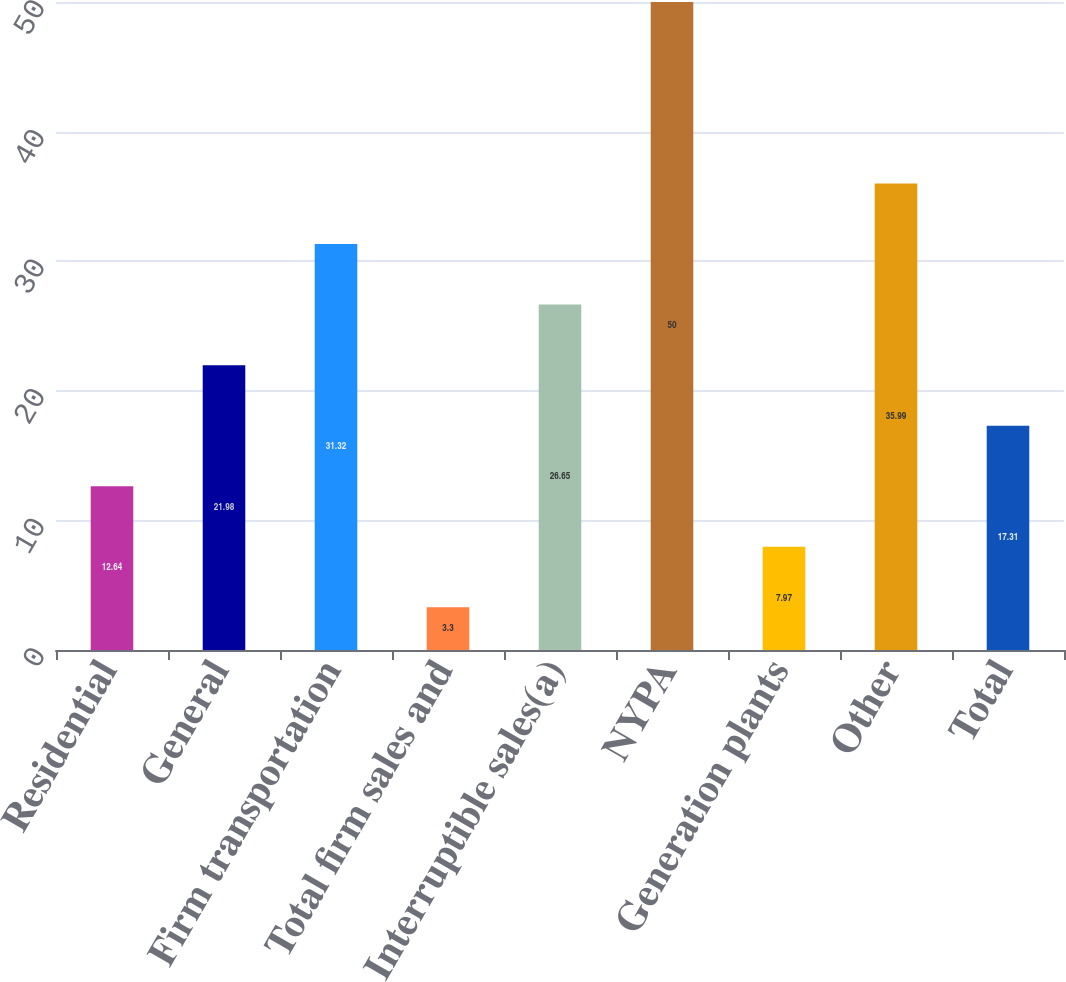Convert chart. <chart><loc_0><loc_0><loc_500><loc_500><bar_chart><fcel>Residential<fcel>General<fcel>Firm transportation<fcel>Total firm sales and<fcel>Interruptible sales(a)<fcel>NYPA<fcel>Generation plants<fcel>Other<fcel>Total<nl><fcel>12.64<fcel>21.98<fcel>31.32<fcel>3.3<fcel>26.65<fcel>50<fcel>7.97<fcel>35.99<fcel>17.31<nl></chart> 